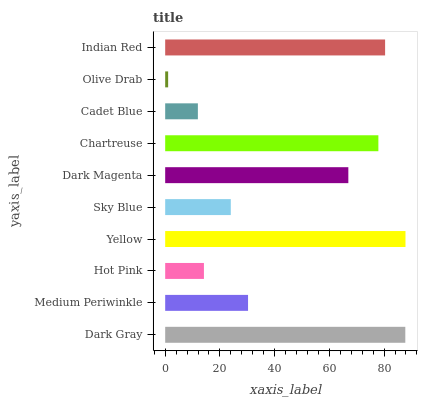Is Olive Drab the minimum?
Answer yes or no. Yes. Is Yellow the maximum?
Answer yes or no. Yes. Is Medium Periwinkle the minimum?
Answer yes or no. No. Is Medium Periwinkle the maximum?
Answer yes or no. No. Is Dark Gray greater than Medium Periwinkle?
Answer yes or no. Yes. Is Medium Periwinkle less than Dark Gray?
Answer yes or no. Yes. Is Medium Periwinkle greater than Dark Gray?
Answer yes or no. No. Is Dark Gray less than Medium Periwinkle?
Answer yes or no. No. Is Dark Magenta the high median?
Answer yes or no. Yes. Is Medium Periwinkle the low median?
Answer yes or no. Yes. Is Cadet Blue the high median?
Answer yes or no. No. Is Olive Drab the low median?
Answer yes or no. No. 